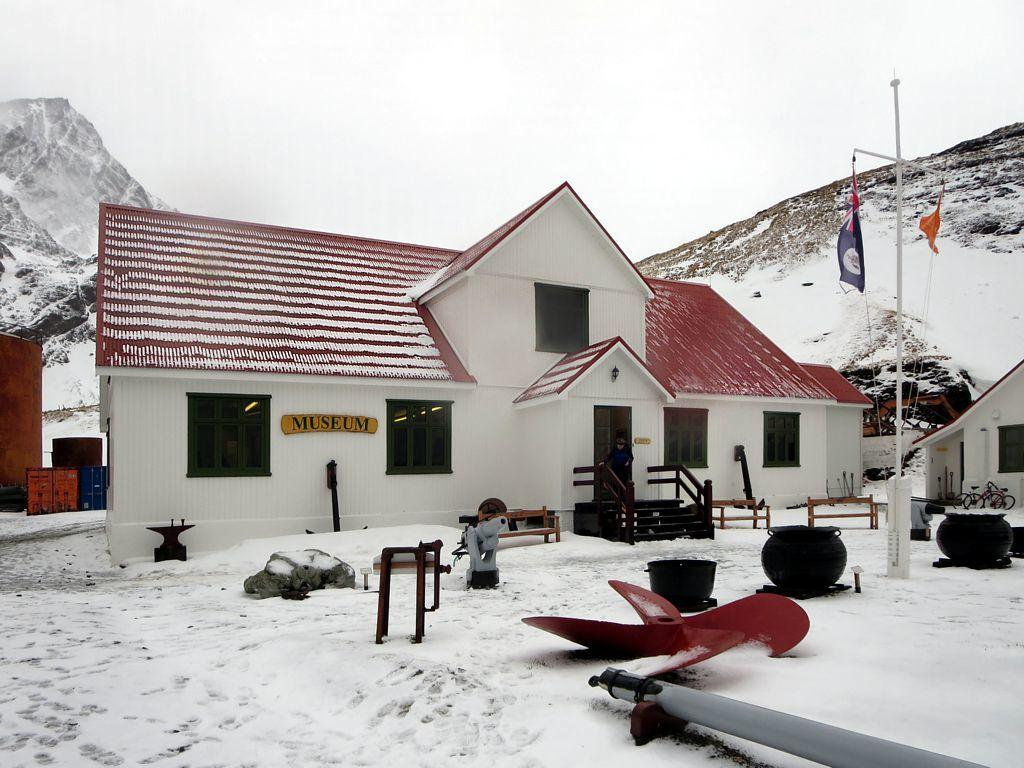What type of structure is present in the image? There is a house in the image. What features can be seen on the house? The house has windows and doors. What is the weather like in the image? There is snow in the image, indicating a cold or wintry weather condition. What is visible in the background of the image? The sky is visible in the image. Can you tell me how many turkeys are standing near the house in the image? There are no turkeys present in the image; it only features a house with snow and a visible sky. 